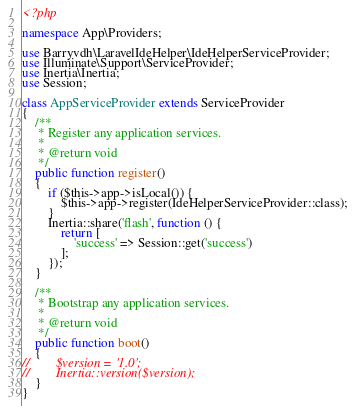<code> <loc_0><loc_0><loc_500><loc_500><_PHP_><?php

namespace App\Providers;

use Barryvdh\LaravelIdeHelper\IdeHelperServiceProvider;
use Illuminate\Support\ServiceProvider;
use Inertia\Inertia;
use Session;

class AppServiceProvider extends ServiceProvider
{
    /**
     * Register any application services.
     *
     * @return void
     */
    public function register()
    {
        if ($this->app->isLocal()) {
            $this->app->register(IdeHelperServiceProvider::class);
        }
        Inertia::share('flash', function () {
            return [
                'success' => Session::get('success')
            ];
        });
    }

    /**
     * Bootstrap any application services.
     *
     * @return void
     */
    public function boot()
    {
//        $version = '1.0';
//        Inertia::version($version);
    }
}
</code> 